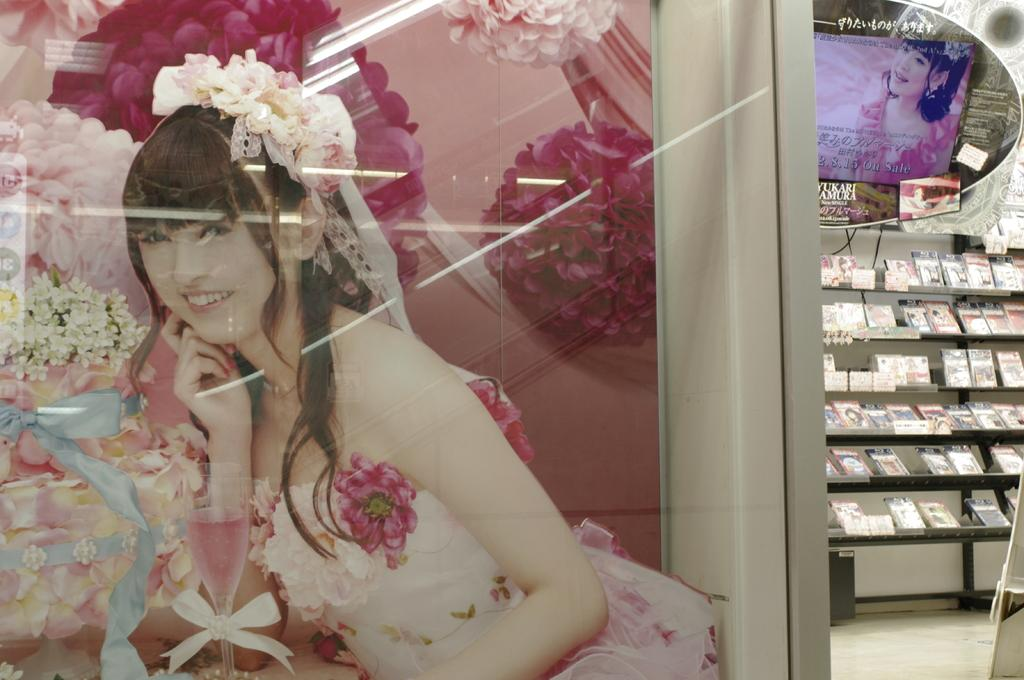What can be seen hanging on the wall in the image? There is a poster in the image. What is located behind the poster in the image? There are objects on a shelf in the background of the image. What surface is visible at the bottom of the image? There is a floor visible at the bottom of the image. What type of milk is being pushed in the image? There is no milk or pushing present in the image. 